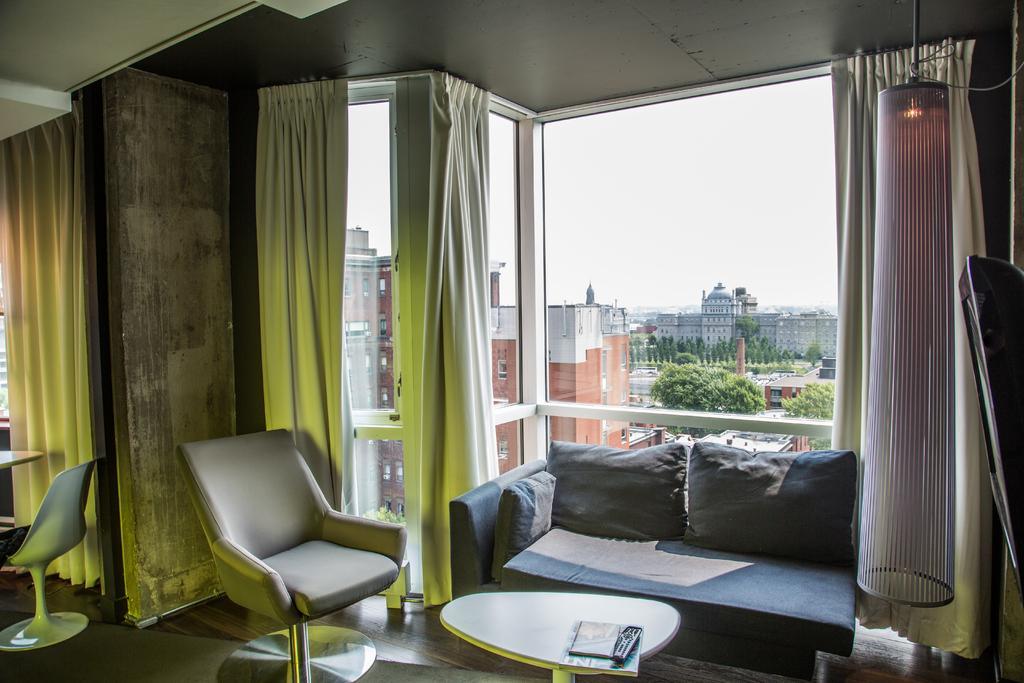Please provide a concise description of this image. This picture is clicked inside the room. Here, we see a sofa with three cushions on it and in front of it, we see a table on which book is placed. We even see two chairs beside that and behind that, we see a window from which we see many buildings and trees and we even see white curtain beside the window. 